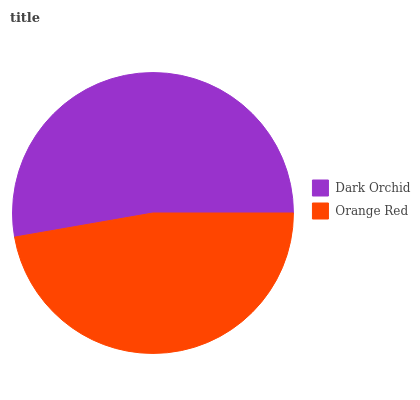Is Orange Red the minimum?
Answer yes or no. Yes. Is Dark Orchid the maximum?
Answer yes or no. Yes. Is Orange Red the maximum?
Answer yes or no. No. Is Dark Orchid greater than Orange Red?
Answer yes or no. Yes. Is Orange Red less than Dark Orchid?
Answer yes or no. Yes. Is Orange Red greater than Dark Orchid?
Answer yes or no. No. Is Dark Orchid less than Orange Red?
Answer yes or no. No. Is Dark Orchid the high median?
Answer yes or no. Yes. Is Orange Red the low median?
Answer yes or no. Yes. Is Orange Red the high median?
Answer yes or no. No. Is Dark Orchid the low median?
Answer yes or no. No. 